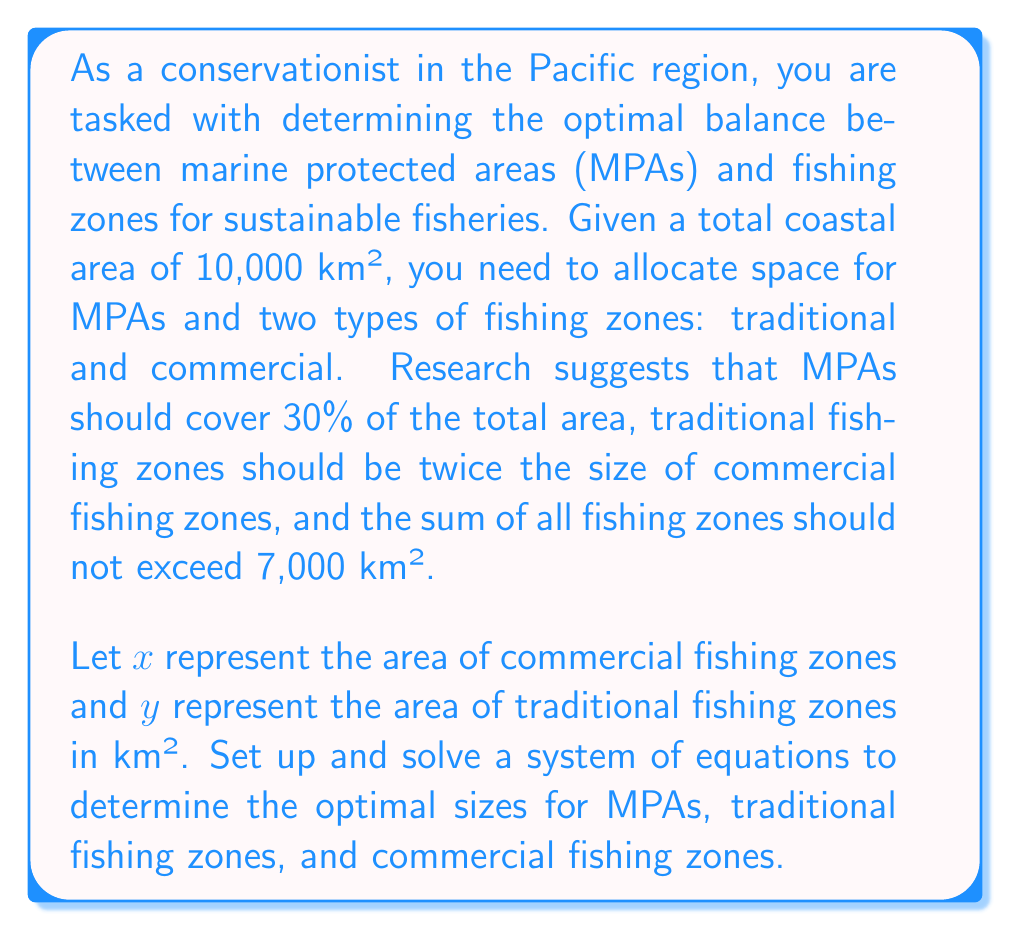Help me with this question. Let's approach this problem step-by-step:

1) First, let's define our variables:
   $x$ = area of commercial fishing zones (km²)
   $y$ = area of traditional fishing zones (km²)
   
2) Now, let's set up our equations based on the given information:

   Equation 1: MPAs should cover 30% of the total area
   $$ 0.3 \cdot 10,000 + x + y = 10,000 $$
   
   Equation 2: Traditional fishing zones should be twice the size of commercial fishing zones
   $$ y = 2x $$
   
   Equation 3: The sum of all fishing zones should not exceed 7,000 km²
   $$ x + y \leq 7,000 $$

3) Let's simplify Equation 1:
   $$ 3,000 + x + y = 10,000 $$
   $$ x + y = 7,000 $$

4) Now we have a system of two equations:
   $$ x + y = 7,000 $$
   $$ y = 2x $$

5) Substitute the second equation into the first:
   $$ x + 2x = 7,000 $$
   $$ 3x = 7,000 $$
   $$ x = \frac{7,000}{3} \approx 2,333.33 $$

6) Now we can find y:
   $$ y = 2x = 2 \cdot 2,333.33 \approx 4,666.67 $$

7) Let's verify that these values satisfy all conditions:
   - MPAs: $10,000 - (2,333.33 + 4,666.67) = 3,000$ km² (30% of total area)
   - Commercial fishing zones: 2,333.33 km²
   - Traditional fishing zones: 4,666.67 km² (twice the commercial zones)
   - Total fishing zones: $2,333.33 + 4,666.67 = 7,000$ km² (not exceeding 7,000 km²)

Therefore, the optimal allocation is:
- MPAs: 3,000 km²
- Commercial fishing zones: 2,333.33 km²
- Traditional fishing zones: 4,666.67 km²
Answer: The optimal allocation is:
MPAs: 3,000 km²
Commercial fishing zones: 2,333.33 km²
Traditional fishing zones: 4,666.67 km² 